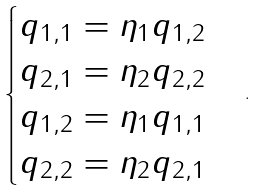<formula> <loc_0><loc_0><loc_500><loc_500>\begin{cases} q _ { 1 , 1 } = \eta _ { 1 } q _ { 1 , 2 } \\ q _ { 2 , 1 } = \eta _ { 2 } q _ { 2 , 2 } \\ q _ { 1 , 2 } = \eta _ { 1 } q _ { 1 , 1 } \\ q _ { 2 , 2 } = \eta _ { 2 } q _ { 2 , 1 } \end{cases} .</formula> 